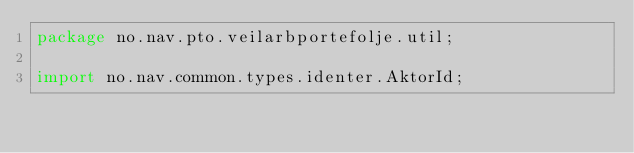<code> <loc_0><loc_0><loc_500><loc_500><_Java_>package no.nav.pto.veilarbportefolje.util;

import no.nav.common.types.identer.AktorId;</code> 